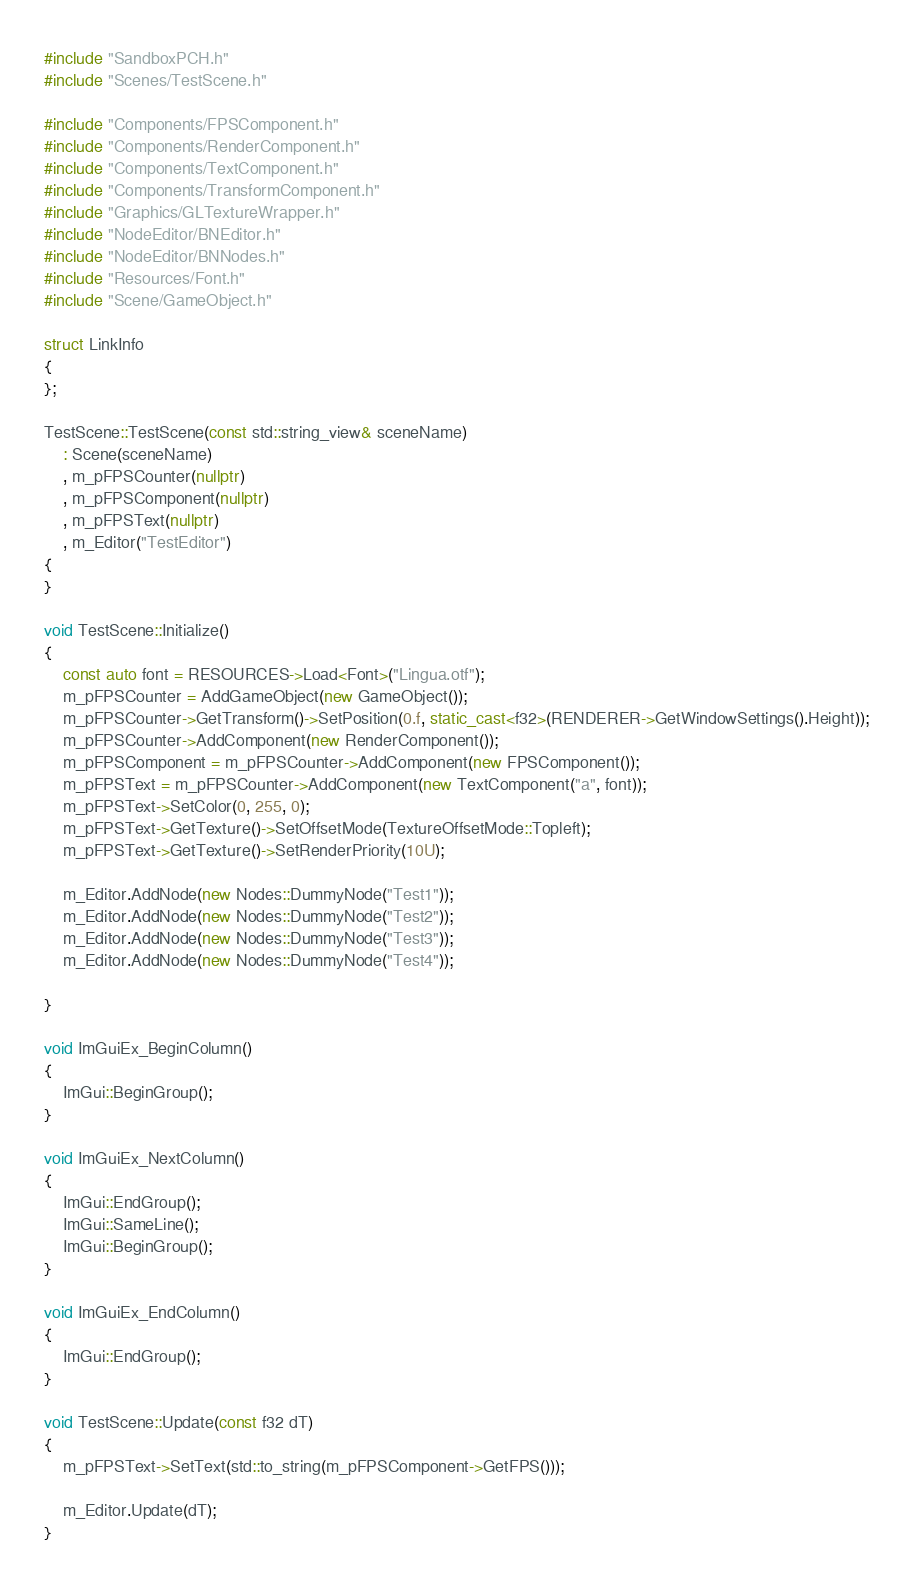<code> <loc_0><loc_0><loc_500><loc_500><_C++_>#include "SandboxPCH.h"
#include "Scenes/TestScene.h"

#include "Components/FPSComponent.h"
#include "Components/RenderComponent.h"
#include "Components/TextComponent.h"
#include "Components/TransformComponent.h"
#include "Graphics/GLTextureWrapper.h"
#include "NodeEditor/BNEditor.h"
#include "NodeEditor/BNNodes.h"
#include "Resources/Font.h"
#include "Scene/GameObject.h"

struct LinkInfo
{
};

TestScene::TestScene(const std::string_view& sceneName)
	: Scene(sceneName)
	, m_pFPSCounter(nullptr)
	, m_pFPSComponent(nullptr)
	, m_pFPSText(nullptr)
	, m_Editor("TestEditor")
{
}

void TestScene::Initialize()
{
	const auto font = RESOURCES->Load<Font>("Lingua.otf");
	m_pFPSCounter = AddGameObject(new GameObject());
	m_pFPSCounter->GetTransform()->SetPosition(0.f, static_cast<f32>(RENDERER->GetWindowSettings().Height));
	m_pFPSCounter->AddComponent(new RenderComponent());
	m_pFPSComponent = m_pFPSCounter->AddComponent(new FPSComponent());
	m_pFPSText = m_pFPSCounter->AddComponent(new TextComponent("a", font));
	m_pFPSText->SetColor(0, 255, 0);
	m_pFPSText->GetTexture()->SetOffsetMode(TextureOffsetMode::Topleft);
	m_pFPSText->GetTexture()->SetRenderPriority(10U);

	m_Editor.AddNode(new Nodes::DummyNode("Test1"));
	m_Editor.AddNode(new Nodes::DummyNode("Test2"));
	m_Editor.AddNode(new Nodes::DummyNode("Test3"));
	m_Editor.AddNode(new Nodes::DummyNode("Test4"));

}

void ImGuiEx_BeginColumn()
{
	ImGui::BeginGroup();
}

void ImGuiEx_NextColumn()
{
	ImGui::EndGroup();
	ImGui::SameLine();
	ImGui::BeginGroup();
}

void ImGuiEx_EndColumn()
{
	ImGui::EndGroup();
}

void TestScene::Update(const f32 dT)
{
	m_pFPSText->SetText(std::to_string(m_pFPSComponent->GetFPS()));

	m_Editor.Update(dT);	
}
</code> 